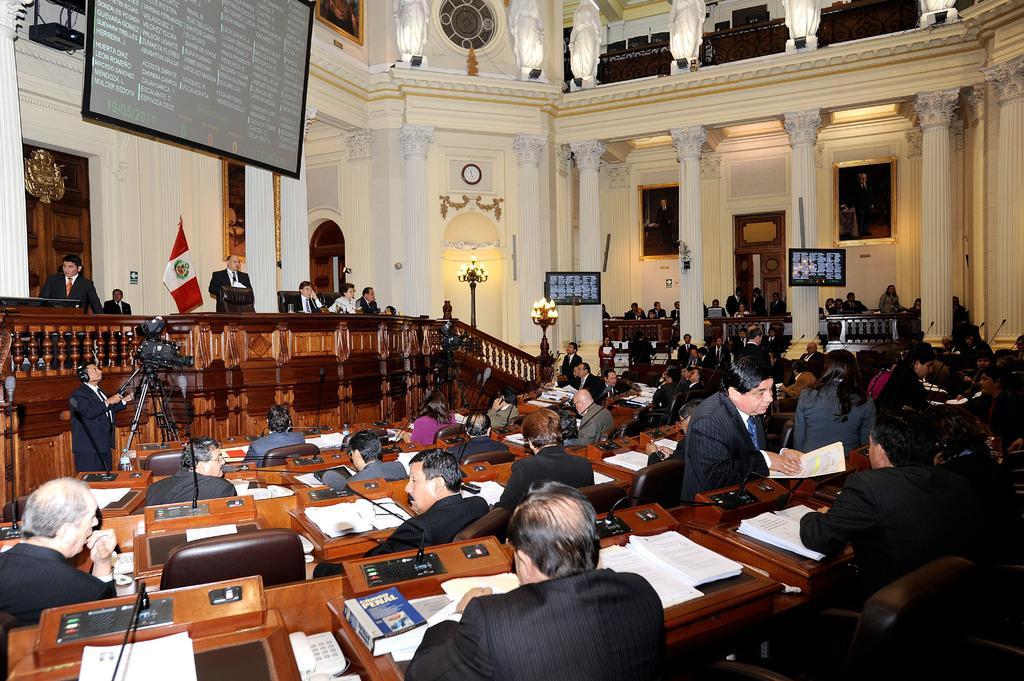Please provide a concise description of this image. In front of the image there are a few people sitting in chairs, in front of them on the table there are some objects. On the stage there are a few people sitting in chairs and some are standing. Behind them there is a flag, wooden door with some object on it and photo frames on the wall. In front of the stage there is a person standing with a video camera in front of him on the stand. On the right side of the image there are pillars, monitors and photo frames on the wall and there are a few people sitting on chairs. In the background of the image there are lamps. At the top of the image there is wall clock, a screen, photo frames and metal rod fence in the first floor. 